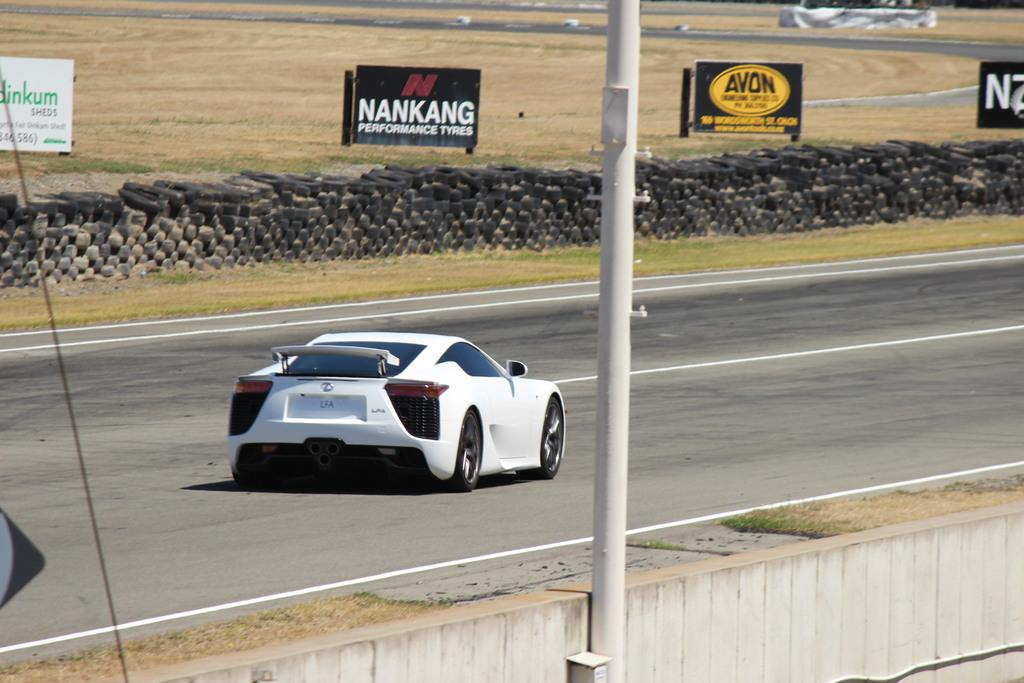What is the main subject of the image? The main subject of the image is a car on the road. What part of the car can be seen in the image? There are tires visible in the image. What is located beside the road in the image? There is a board beside the road in the image. What is in the middle of the image? There is a pole in the middle of the image. What type of value is being produced by the car in the image? The image does not show the car producing any value; it is simply a car on the road. What thought is being expressed by the pole in the image? The pole in the image is not expressing any thought; it is a stationary object. 